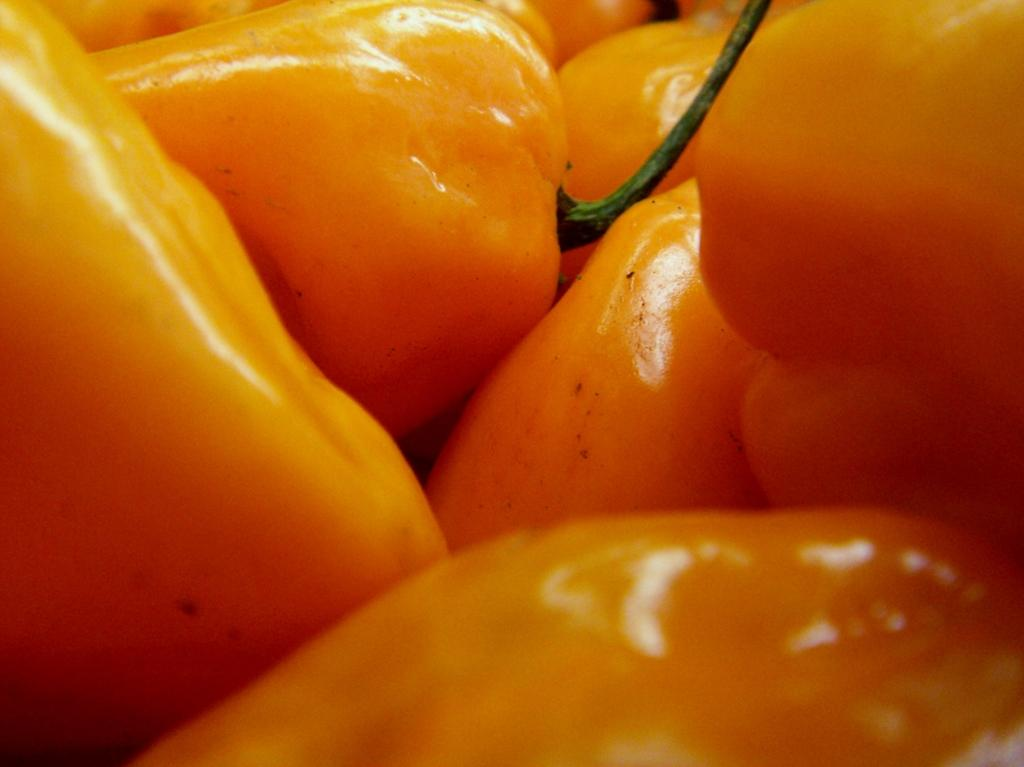What color are the peppers in the image? The peppers in the image are yellow. How many peppers can be seen in the image? There are many yellow peppers in the image. What type of plantation is visible in the image? There is no plantation present in the image; it only features yellow peppers. What month is it in the image? The image does not provide any information about the month or time of year. 